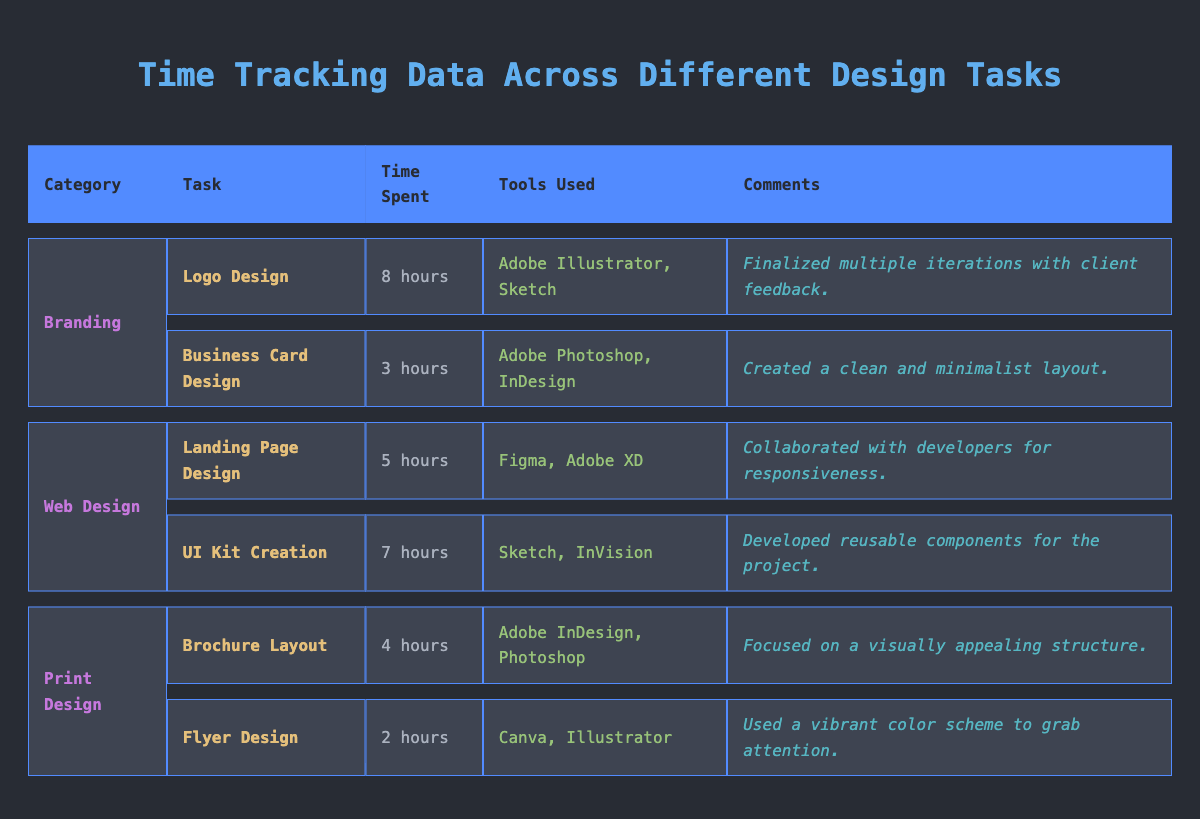What is the total time spent on Branding tasks? The tasks under Branding are Logo Design (8 hours) and Business Card Design (3 hours). To find the total time, we add these two values: 8 + 3 = 11 hours.
Answer: 11 hours Which tool was used for the UI Kit Creation task? The UI Kit Creation task lists the tools used as Sketch and InVision. Therefore, these are the tools used for this task.
Answer: Sketch, InVision Is the time spent on Flyer Design less than the time spent on Brochure Layout? Flyer Design took 2 hours while Brochure Layout took 4 hours. Since 2 is less than 4, the statement is true.
Answer: Yes What is the average time spent on all Print Design tasks? The Print Design tasks are Brochure Layout (4 hours) and Flyer Design (2 hours). The total time for these tasks is 4 + 2 = 6 hours. There are 2 tasks, so the average time is 6 / 2 = 3 hours.
Answer: 3 hours Which task took the most time and how long did it take? By reviewing the time spent on each task, we find Logo Design took 8 hours, which is the highest compared to other tasks.
Answer: Logo Design, 8 hours Are Adobe Illustrator and Adobe Photoshop both used in Branding tasks? Adobe Illustrator is used in Logo Design and Adobe Photoshop is used in Business Card Design. Since they are both used, the answer is yes.
Answer: No How many total hours were spent on Web Design tasks? The Web Design tasks are Landing Page Design (5 hours) and UI Kit Creation (7 hours). To find the total, we add 5 + 7 = 12 hours.
Answer: 12 hours Which category has the least time spent in total? The time spent in each category are: Branding (11 hours), Web Design (12 hours), and Print Design (6 hours). Therefore, Print Design has the least time spent.
Answer: Print Design 